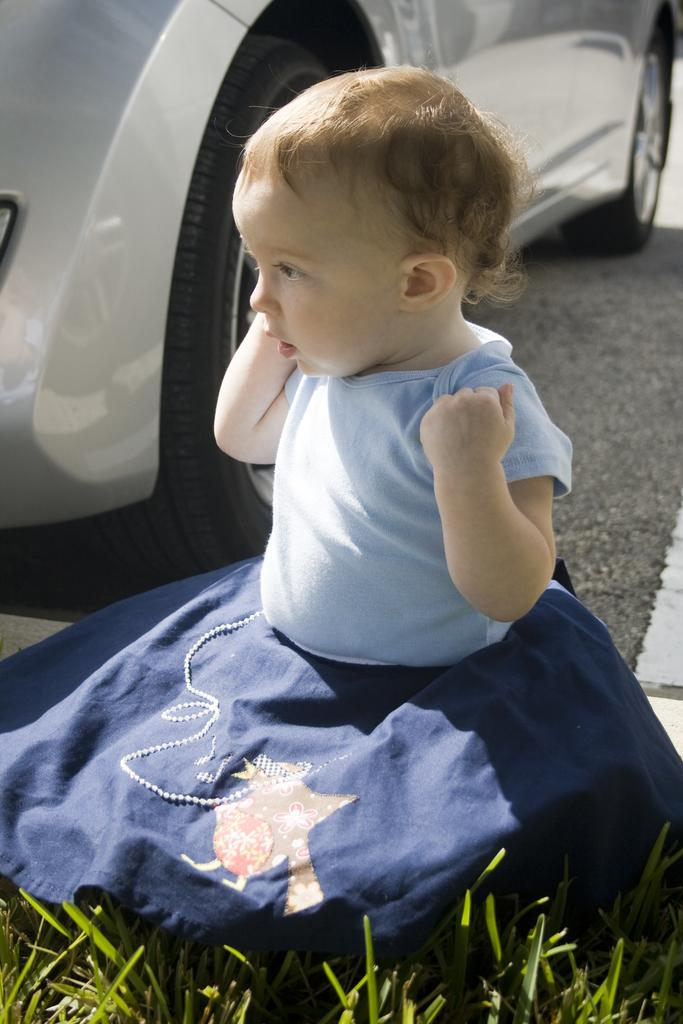Who is present in the image? There is a person in the image. What is the person wearing? The person is wearing a blue dress. What type of terrain is visible in the image? There is grass visible in the image. What can be seen in the background of the image? There is a vehicle on the road in the background of the image. What type of rice is being cooked in the image? There is no rice present in the image; it features a person wearing a blue dress, grass, and a vehicle on the road in the background. 